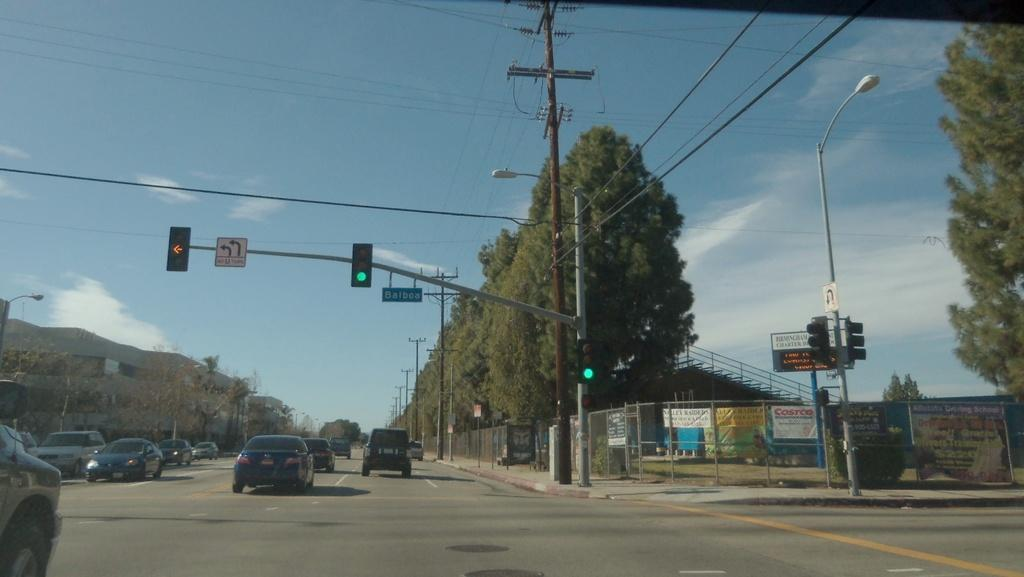Provide a one-sentence caption for the provided image. Cars on the road coming the lights with a sign to turn left. 